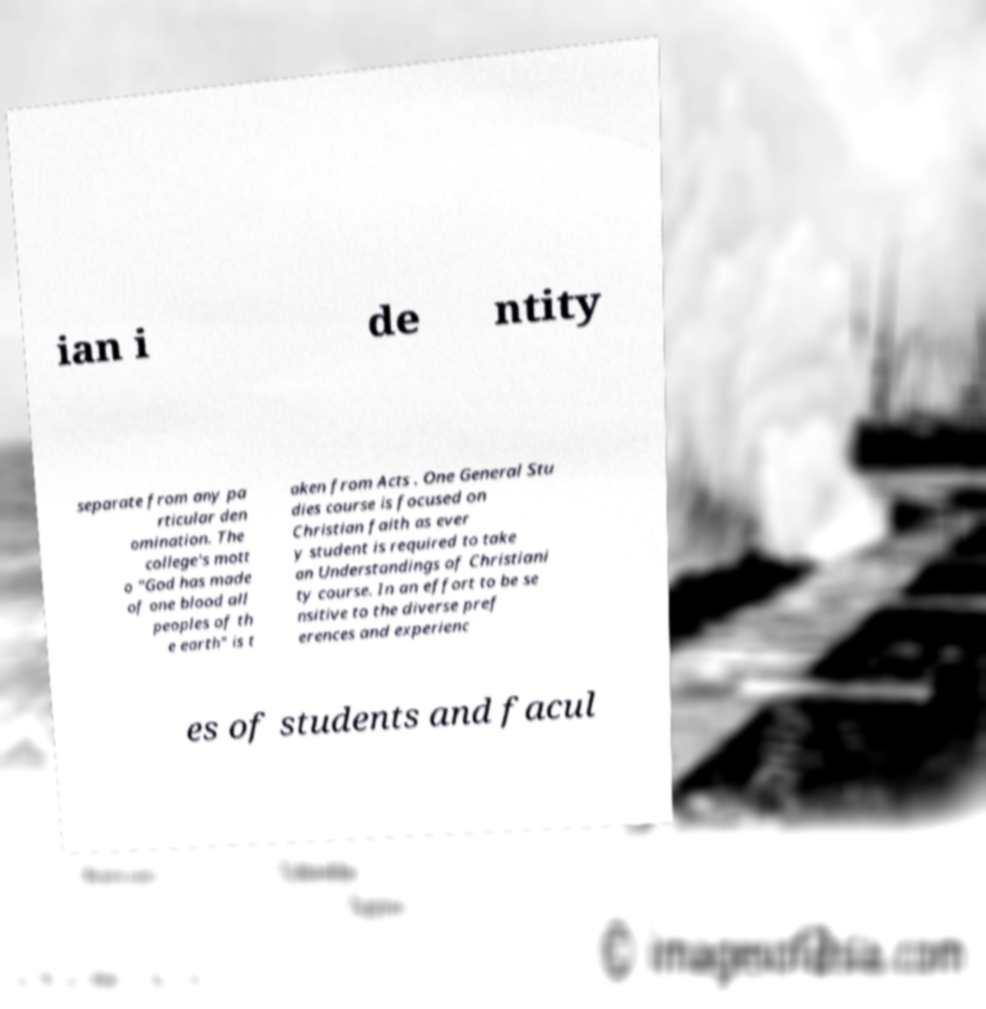Can you accurately transcribe the text from the provided image for me? ian i de ntity separate from any pa rticular den omination. The college's mott o "God has made of one blood all peoples of th e earth" is t aken from Acts . One General Stu dies course is focused on Christian faith as ever y student is required to take an Understandings of Christiani ty course. In an effort to be se nsitive to the diverse pref erences and experienc es of students and facul 